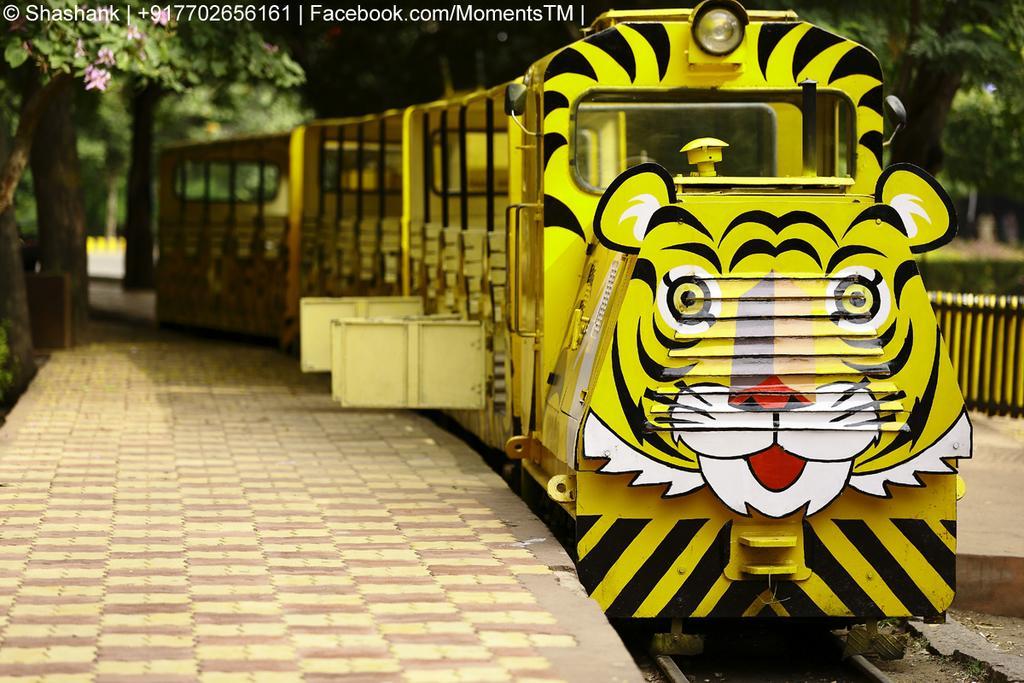How would you summarize this image in a sentence or two? In this image we can see a train on the track, there we can see pavement on both sides of the track, few trees, a fence, few flowers and a light hanging from the tree. 